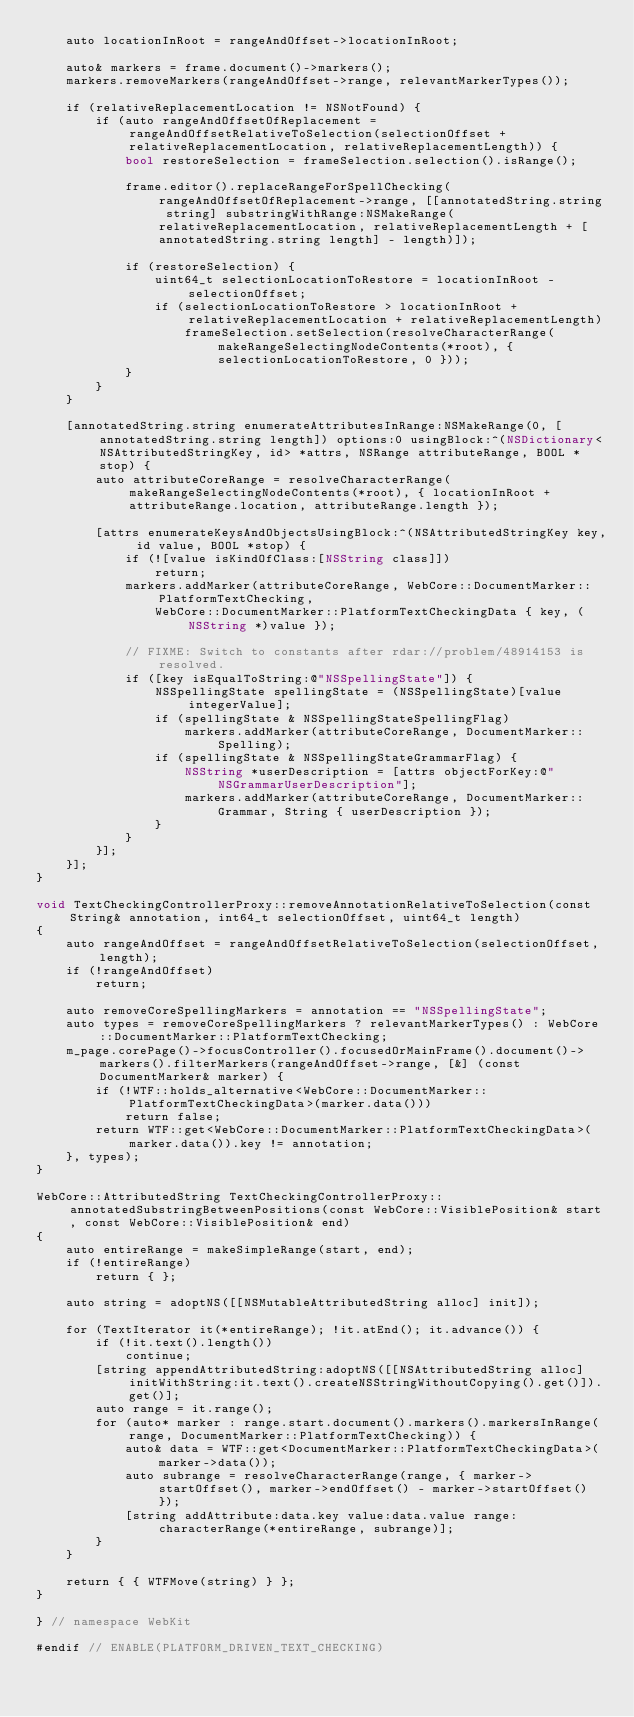Convert code to text. <code><loc_0><loc_0><loc_500><loc_500><_ObjectiveC_>    auto locationInRoot = rangeAndOffset->locationInRoot;

    auto& markers = frame.document()->markers();
    markers.removeMarkers(rangeAndOffset->range, relevantMarkerTypes());

    if (relativeReplacementLocation != NSNotFound) {
        if (auto rangeAndOffsetOfReplacement = rangeAndOffsetRelativeToSelection(selectionOffset + relativeReplacementLocation, relativeReplacementLength)) {
            bool restoreSelection = frameSelection.selection().isRange();

            frame.editor().replaceRangeForSpellChecking(rangeAndOffsetOfReplacement->range, [[annotatedString.string string] substringWithRange:NSMakeRange(relativeReplacementLocation, relativeReplacementLength + [annotatedString.string length] - length)]);

            if (restoreSelection) {
                uint64_t selectionLocationToRestore = locationInRoot - selectionOffset;
                if (selectionLocationToRestore > locationInRoot + relativeReplacementLocation + relativeReplacementLength)
                    frameSelection.setSelection(resolveCharacterRange(makeRangeSelectingNodeContents(*root), { selectionLocationToRestore, 0 }));
            }
        }
    }

    [annotatedString.string enumerateAttributesInRange:NSMakeRange(0, [annotatedString.string length]) options:0 usingBlock:^(NSDictionary<NSAttributedStringKey, id> *attrs, NSRange attributeRange, BOOL *stop) {
        auto attributeCoreRange = resolveCharacterRange(makeRangeSelectingNodeContents(*root), { locationInRoot + attributeRange.location, attributeRange.length });

        [attrs enumerateKeysAndObjectsUsingBlock:^(NSAttributedStringKey key, id value, BOOL *stop) {
            if (![value isKindOfClass:[NSString class]])
                return;
            markers.addMarker(attributeCoreRange, WebCore::DocumentMarker::PlatformTextChecking,
                WebCore::DocumentMarker::PlatformTextCheckingData { key, (NSString *)value });

            // FIXME: Switch to constants after rdar://problem/48914153 is resolved.
            if ([key isEqualToString:@"NSSpellingState"]) {
                NSSpellingState spellingState = (NSSpellingState)[value integerValue];
                if (spellingState & NSSpellingStateSpellingFlag)
                    markers.addMarker(attributeCoreRange, DocumentMarker::Spelling);
                if (spellingState & NSSpellingStateGrammarFlag) {
                    NSString *userDescription = [attrs objectForKey:@"NSGrammarUserDescription"];
                    markers.addMarker(attributeCoreRange, DocumentMarker::Grammar, String { userDescription });
                }
            }
        }];
    }];
}

void TextCheckingControllerProxy::removeAnnotationRelativeToSelection(const String& annotation, int64_t selectionOffset, uint64_t length)
{
    auto rangeAndOffset = rangeAndOffsetRelativeToSelection(selectionOffset, length);
    if (!rangeAndOffset)
        return;

    auto removeCoreSpellingMarkers = annotation == "NSSpellingState";
    auto types = removeCoreSpellingMarkers ? relevantMarkerTypes() : WebCore::DocumentMarker::PlatformTextChecking;
    m_page.corePage()->focusController().focusedOrMainFrame().document()->markers().filterMarkers(rangeAndOffset->range, [&] (const DocumentMarker& marker) {
        if (!WTF::holds_alternative<WebCore::DocumentMarker::PlatformTextCheckingData>(marker.data()))
            return false;
        return WTF::get<WebCore::DocumentMarker::PlatformTextCheckingData>(marker.data()).key != annotation;
    }, types);
}

WebCore::AttributedString TextCheckingControllerProxy::annotatedSubstringBetweenPositions(const WebCore::VisiblePosition& start, const WebCore::VisiblePosition& end)
{
    auto entireRange = makeSimpleRange(start, end);
    if (!entireRange)
        return { };

    auto string = adoptNS([[NSMutableAttributedString alloc] init]);

    for (TextIterator it(*entireRange); !it.atEnd(); it.advance()) {
        if (!it.text().length())
            continue;
        [string appendAttributedString:adoptNS([[NSAttributedString alloc] initWithString:it.text().createNSStringWithoutCopying().get()]).get()];
        auto range = it.range();
        for (auto* marker : range.start.document().markers().markersInRange(range, DocumentMarker::PlatformTextChecking)) {
            auto& data = WTF::get<DocumentMarker::PlatformTextCheckingData>(marker->data());
            auto subrange = resolveCharacterRange(range, { marker->startOffset(), marker->endOffset() - marker->startOffset() });
            [string addAttribute:data.key value:data.value range:characterRange(*entireRange, subrange)];
        }
    }

    return { { WTFMove(string) } };
}

} // namespace WebKit

#endif // ENABLE(PLATFORM_DRIVEN_TEXT_CHECKING)
</code> 